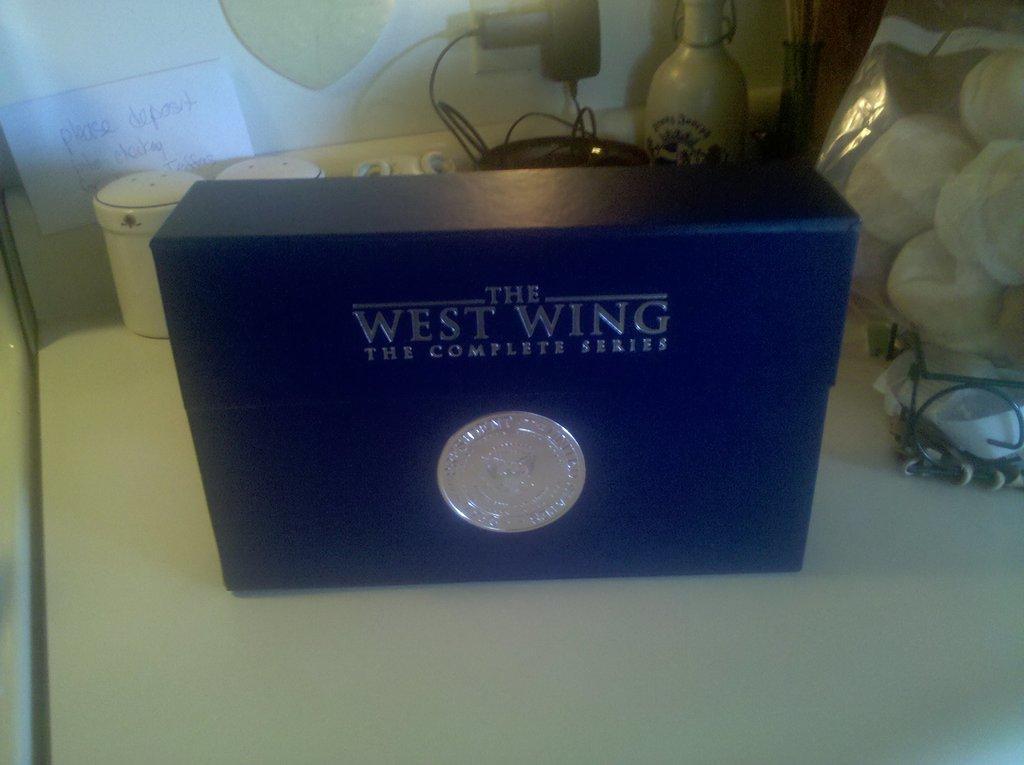Can you describe this image briefly? In the image there is a blue box kept on a table and around that box there are many other items, in the background there is a paper attached to the wall and something is mentioned on the paper. 